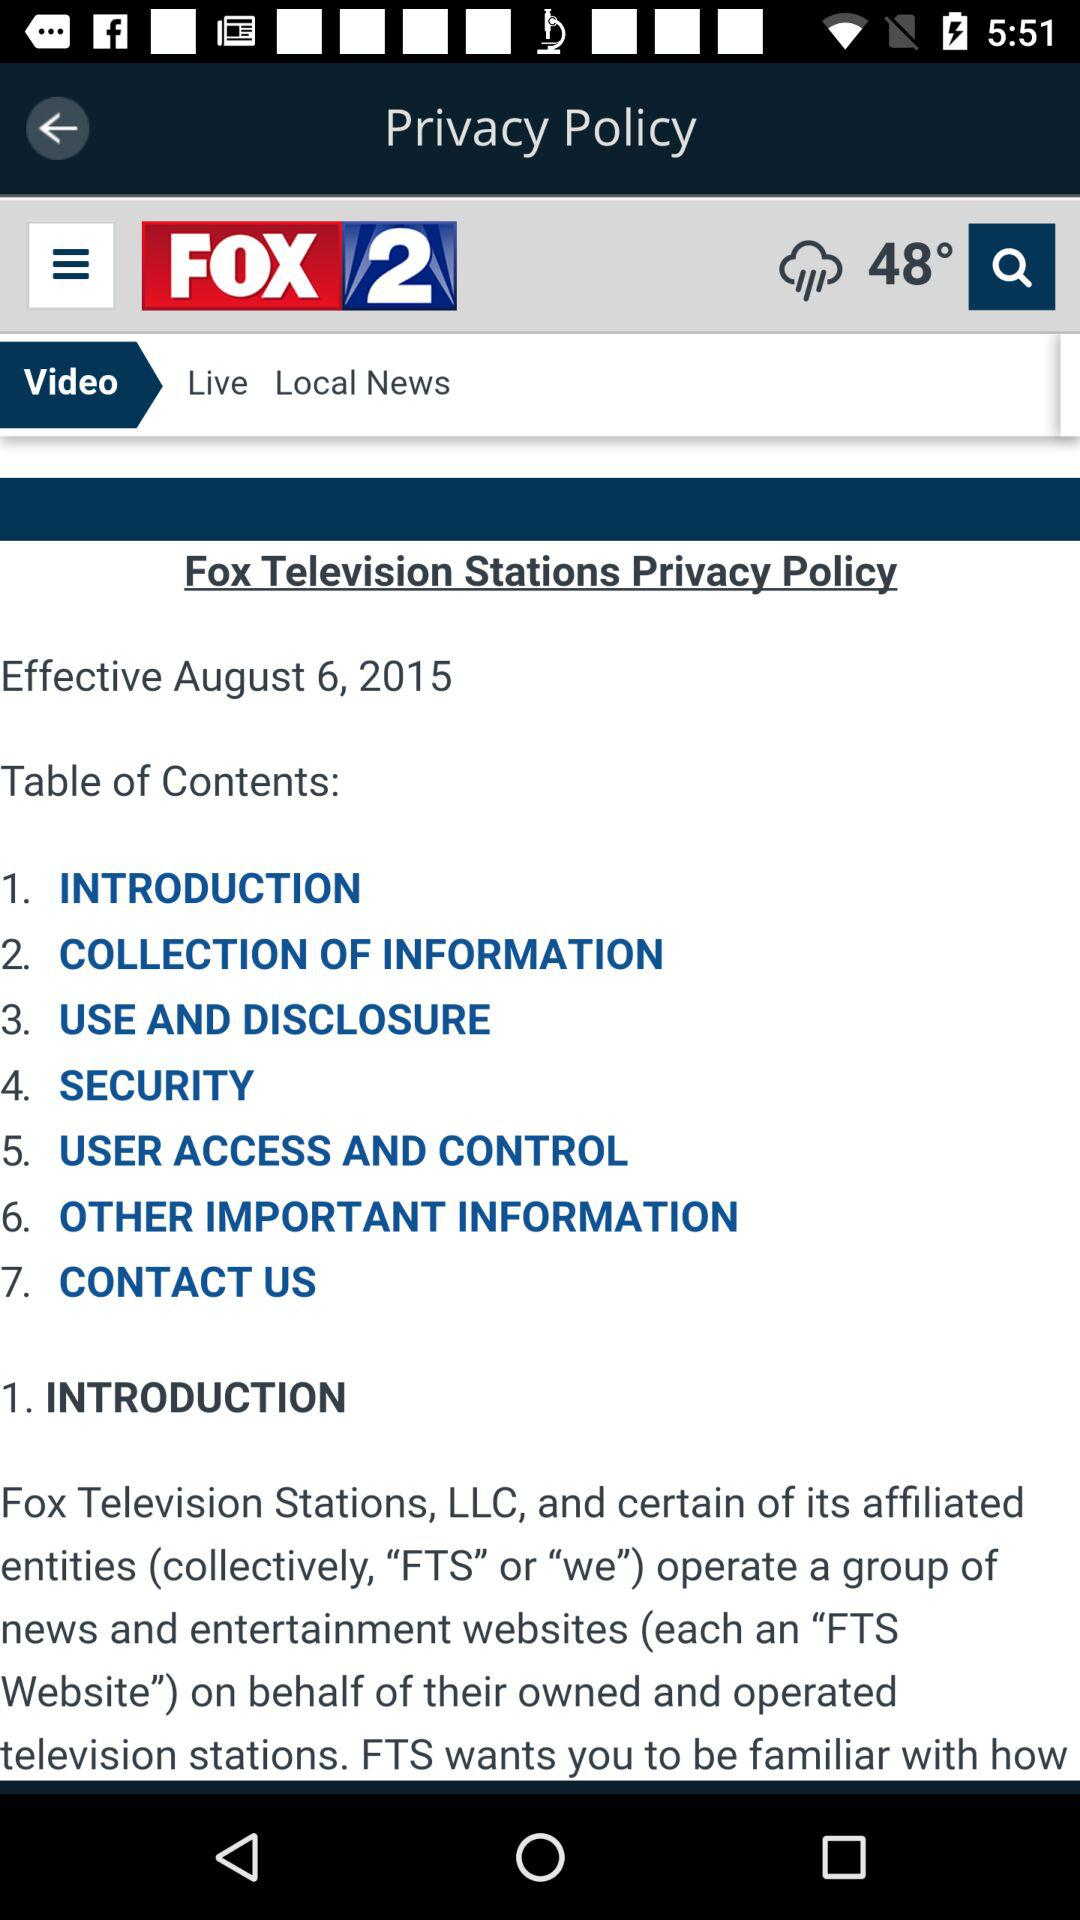How many sections are there in the table of contents?
Answer the question using a single word or phrase. 7 